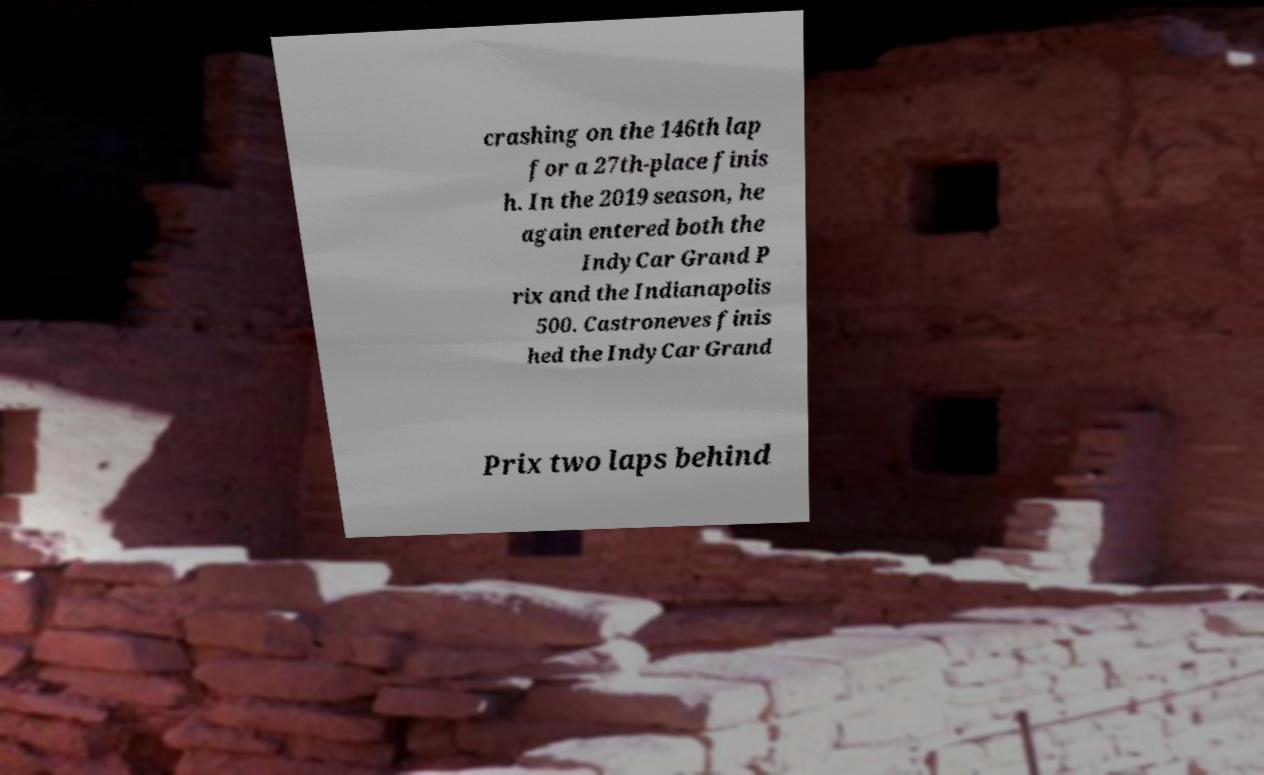Can you accurately transcribe the text from the provided image for me? crashing on the 146th lap for a 27th-place finis h. In the 2019 season, he again entered both the IndyCar Grand P rix and the Indianapolis 500. Castroneves finis hed the IndyCar Grand Prix two laps behind 